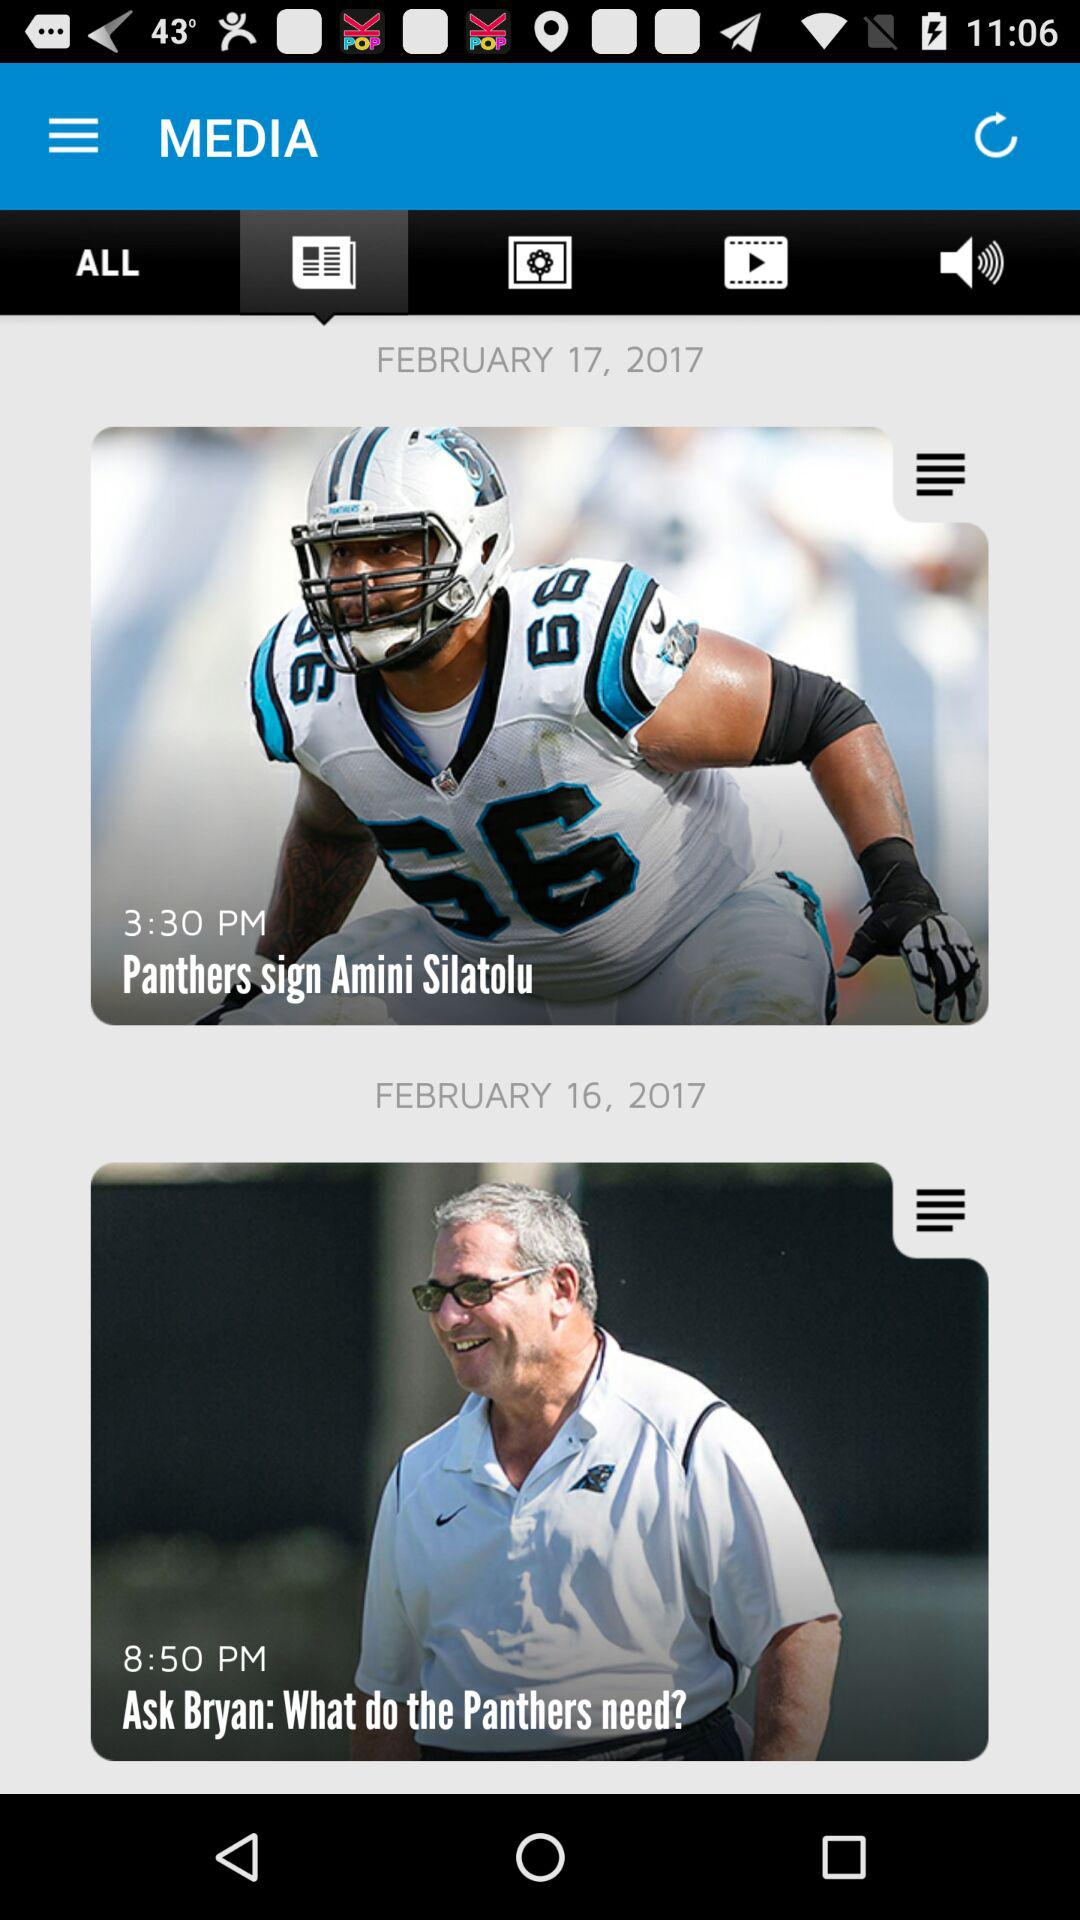How many posts are there?
Answer the question using a single word or phrase. 2 